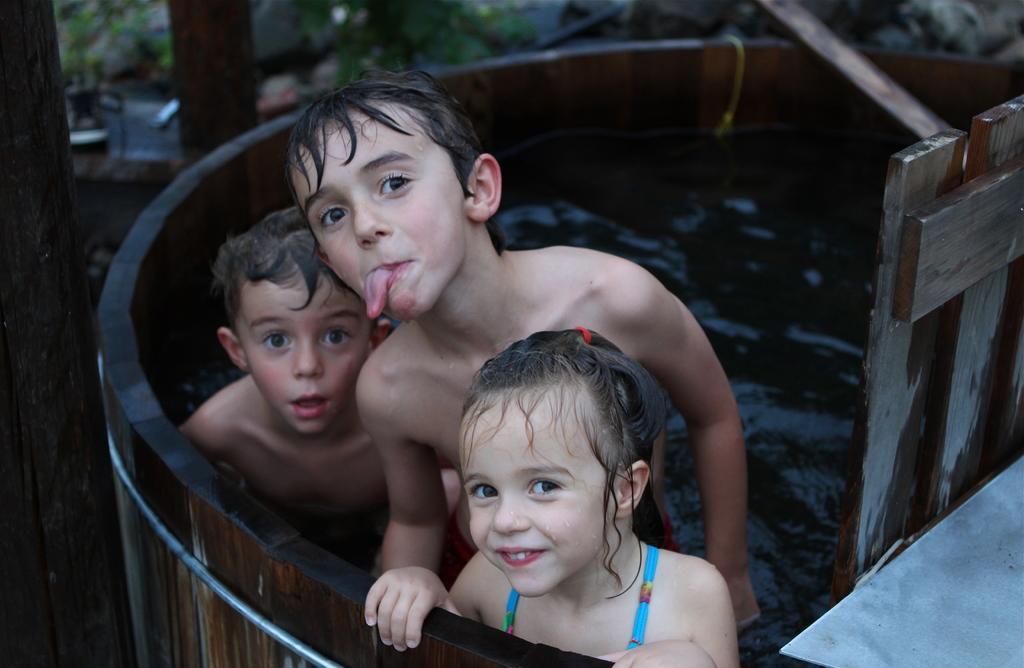Could you give a brief overview of what you see in this image? In this image, we can see kids in the tank. There is a pole on the left side of the image. 